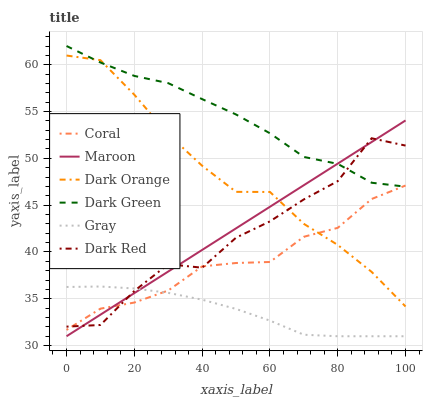Does Gray have the minimum area under the curve?
Answer yes or no. Yes. Does Dark Green have the maximum area under the curve?
Answer yes or no. Yes. Does Dark Red have the minimum area under the curve?
Answer yes or no. No. Does Dark Red have the maximum area under the curve?
Answer yes or no. No. Is Maroon the smoothest?
Answer yes or no. Yes. Is Dark Red the roughest?
Answer yes or no. Yes. Is Gray the smoothest?
Answer yes or no. No. Is Gray the roughest?
Answer yes or no. No. Does Gray have the lowest value?
Answer yes or no. Yes. Does Dark Red have the lowest value?
Answer yes or no. No. Does Dark Green have the highest value?
Answer yes or no. Yes. Does Dark Red have the highest value?
Answer yes or no. No. Is Gray less than Dark Green?
Answer yes or no. Yes. Is Dark Green greater than Gray?
Answer yes or no. Yes. Does Dark Red intersect Gray?
Answer yes or no. Yes. Is Dark Red less than Gray?
Answer yes or no. No. Is Dark Red greater than Gray?
Answer yes or no. No. Does Gray intersect Dark Green?
Answer yes or no. No. 